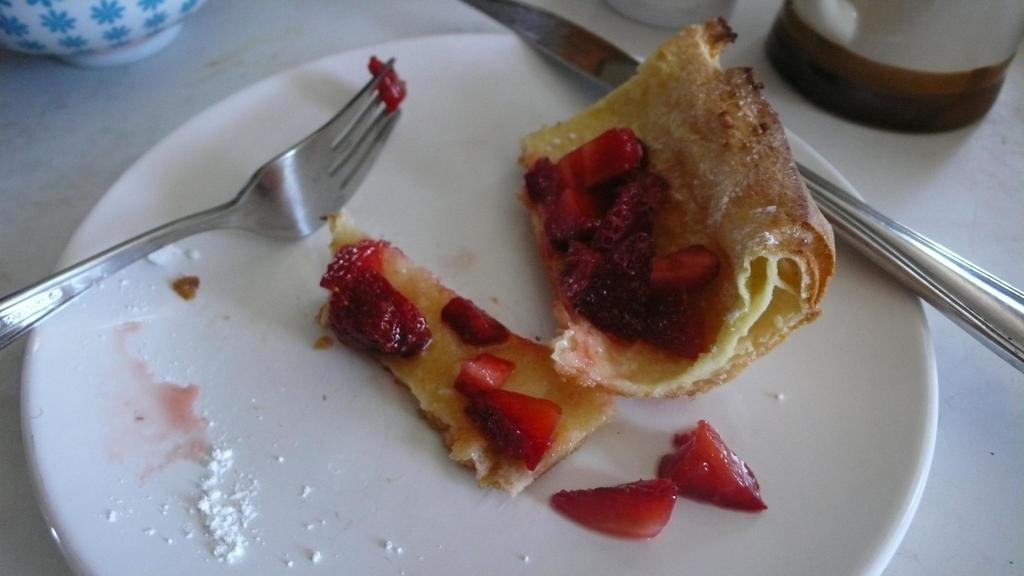What is on the plate in the image? There is fruit salad and bread on the plate in the image. What utensils are present in the image? A fork and knife are present in the image. What else can be seen in the image besides the plate and utensils? There is a bowl in the image. What type of seed is used to grow the yoke in the image? There is no yoke or seed present in the image; it features a plate with fruit salad and bread, along with a fork, knife, and bowl. 